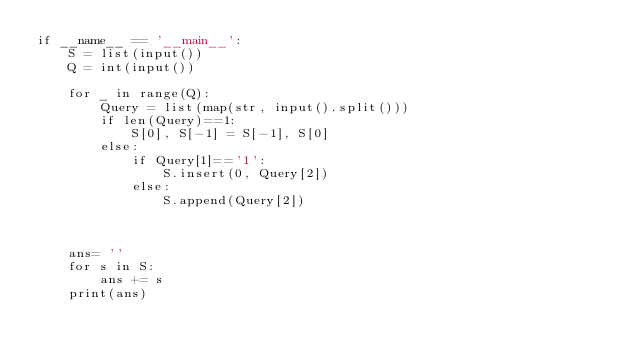Convert code to text. <code><loc_0><loc_0><loc_500><loc_500><_Python_>if __name__ == '__main__':
    S = list(input())
    Q = int(input())

    for _ in range(Q):
        Query = list(map(str, input().split()))
        if len(Query)==1:
            S[0], S[-1] = S[-1], S[0]
        else:
            if Query[1]=='1':
                S.insert(0, Query[2])
            else:
                S.append(Query[2])
        

    
    ans= ''
    for s in S:
        ans += s
    print(ans)</code> 